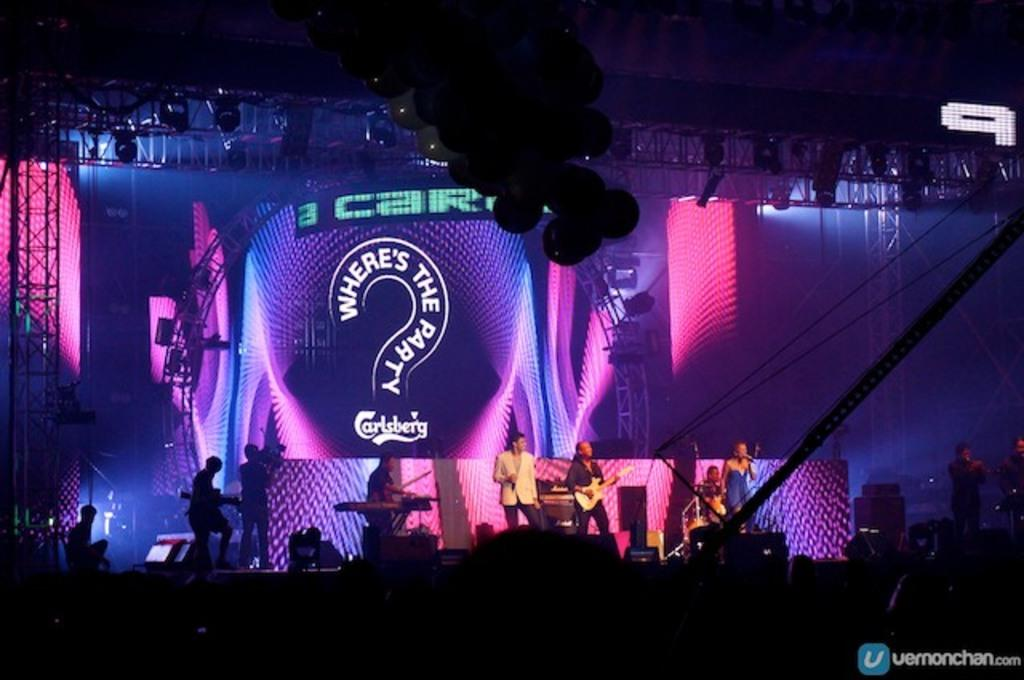What type of event is depicted in the image? The image is from a musical concert. What can be seen at the top of the image? There are lights at the top of the image. What is happening in the middle of the image? There are people in the middle of the image. What are the people doing in the image? The people are playing musical instruments. Can you tell me how many hoses are visible in the image? There are no hoses present in the image. What type of advice is being given by the person in the cap in the image? There is no person in a cap giving advice in the image; it features people playing musical instruments at a concert. 